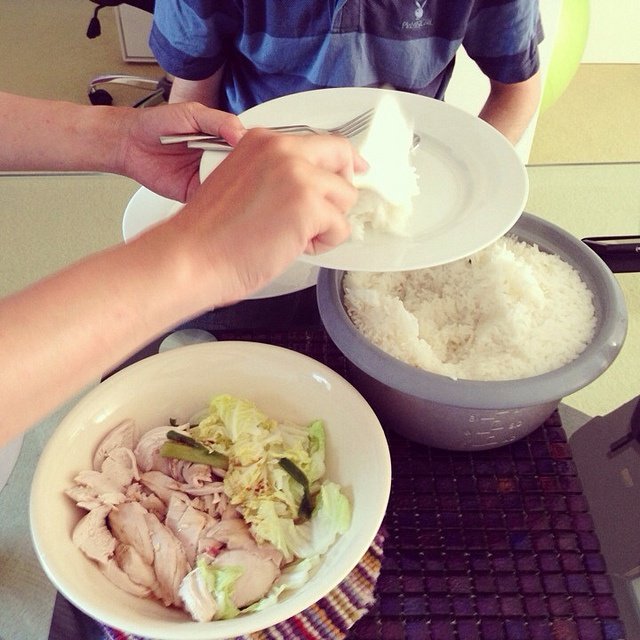Describe the objects in this image and their specific colors. I can see dining table in gray, tan, black, and beige tones, bowl in gray, tan, and beige tones, people in gray, tan, and salmon tones, bowl in gray, beige, darkgray, and tan tones, and people in gray, navy, and purple tones in this image. 